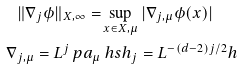<formula> <loc_0><loc_0><loc_500><loc_500>\| \nabla _ { j } \phi \| _ { X , \infty } = & \sup _ { x \in X , \mu } | \nabla _ { j , \mu } \phi ( x ) | \\ \nabla _ { j , \mu } = L ^ { j } \ p a _ { \mu } & \ h s h _ { j } = L ^ { - ( d - 2 ) j / 2 } h \\</formula> 